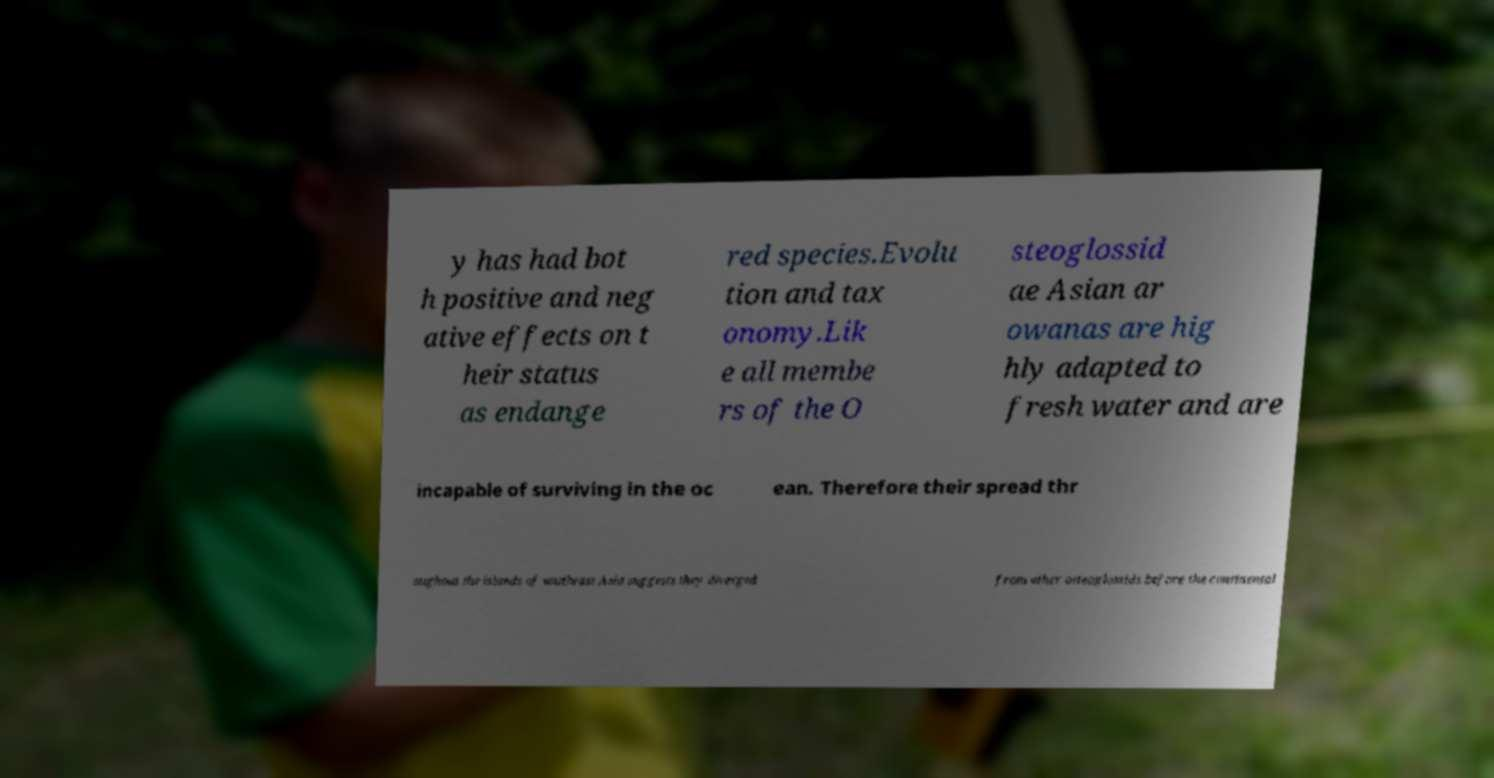There's text embedded in this image that I need extracted. Can you transcribe it verbatim? y has had bot h positive and neg ative effects on t heir status as endange red species.Evolu tion and tax onomy.Lik e all membe rs of the O steoglossid ae Asian ar owanas are hig hly adapted to fresh water and are incapable of surviving in the oc ean. Therefore their spread thr oughout the islands of southeast Asia suggests they diverged from other osteoglossids before the continental 